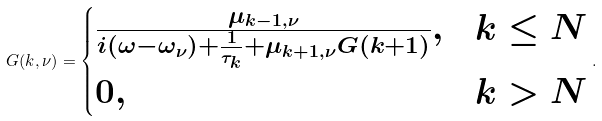Convert formula to latex. <formula><loc_0><loc_0><loc_500><loc_500>G ( k , \nu ) = \begin{cases} \frac { \mu _ { k - 1 , \nu } } { i ( \omega - \omega _ { \nu } ) + \frac { 1 } { \tau _ { k } } + \mu _ { k + 1 , \nu } G ( k + 1 ) } , & k \leq N \\ 0 , & k > N \end{cases} .</formula> 